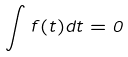<formula> <loc_0><loc_0><loc_500><loc_500>\int f ( t ) d t = 0</formula> 